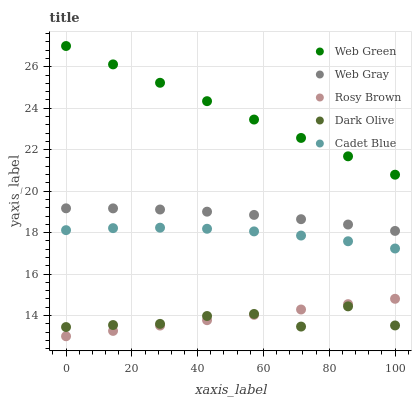Does Dark Olive have the minimum area under the curve?
Answer yes or no. Yes. Does Web Green have the maximum area under the curve?
Answer yes or no. Yes. Does Rosy Brown have the minimum area under the curve?
Answer yes or no. No. Does Rosy Brown have the maximum area under the curve?
Answer yes or no. No. Is Rosy Brown the smoothest?
Answer yes or no. Yes. Is Dark Olive the roughest?
Answer yes or no. Yes. Is Web Gray the smoothest?
Answer yes or no. No. Is Web Gray the roughest?
Answer yes or no. No. Does Rosy Brown have the lowest value?
Answer yes or no. Yes. Does Web Gray have the lowest value?
Answer yes or no. No. Does Web Green have the highest value?
Answer yes or no. Yes. Does Rosy Brown have the highest value?
Answer yes or no. No. Is Rosy Brown less than Web Green?
Answer yes or no. Yes. Is Cadet Blue greater than Dark Olive?
Answer yes or no. Yes. Does Dark Olive intersect Rosy Brown?
Answer yes or no. Yes. Is Dark Olive less than Rosy Brown?
Answer yes or no. No. Is Dark Olive greater than Rosy Brown?
Answer yes or no. No. Does Rosy Brown intersect Web Green?
Answer yes or no. No. 